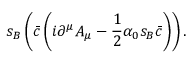<formula> <loc_0><loc_0><loc_500><loc_500>s _ { B } \left ( { \bar { c } } \left ( i \partial ^ { \mu } A _ { \mu } - { \frac { 1 } { 2 } } \alpha _ { 0 } s _ { B } { \bar { c } } \right ) \right ) .</formula> 